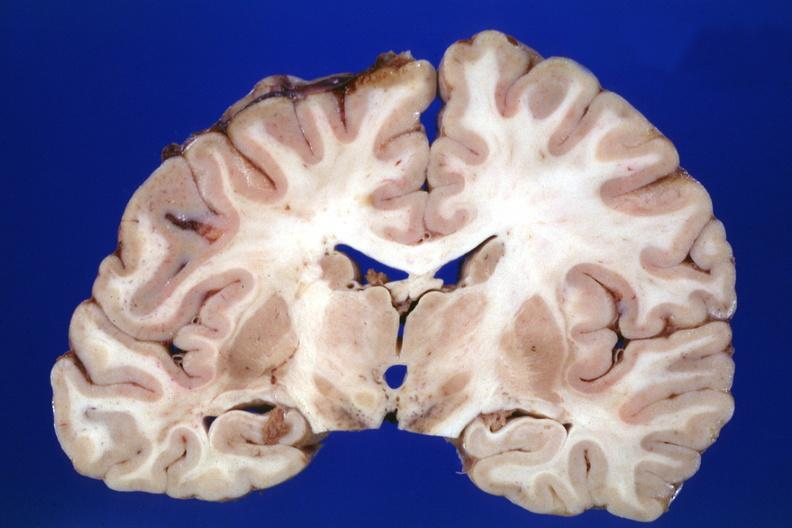what was the lesion in?
Answer the question using a single word or phrase. In pons 